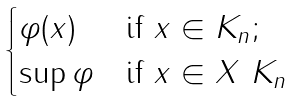Convert formula to latex. <formula><loc_0><loc_0><loc_500><loc_500>\begin{cases} \varphi ( x ) & \text {if $x\in K_{n}$;} \\ \sup \varphi & \text {if $x\in X\ K_{n}$} \end{cases}</formula> 